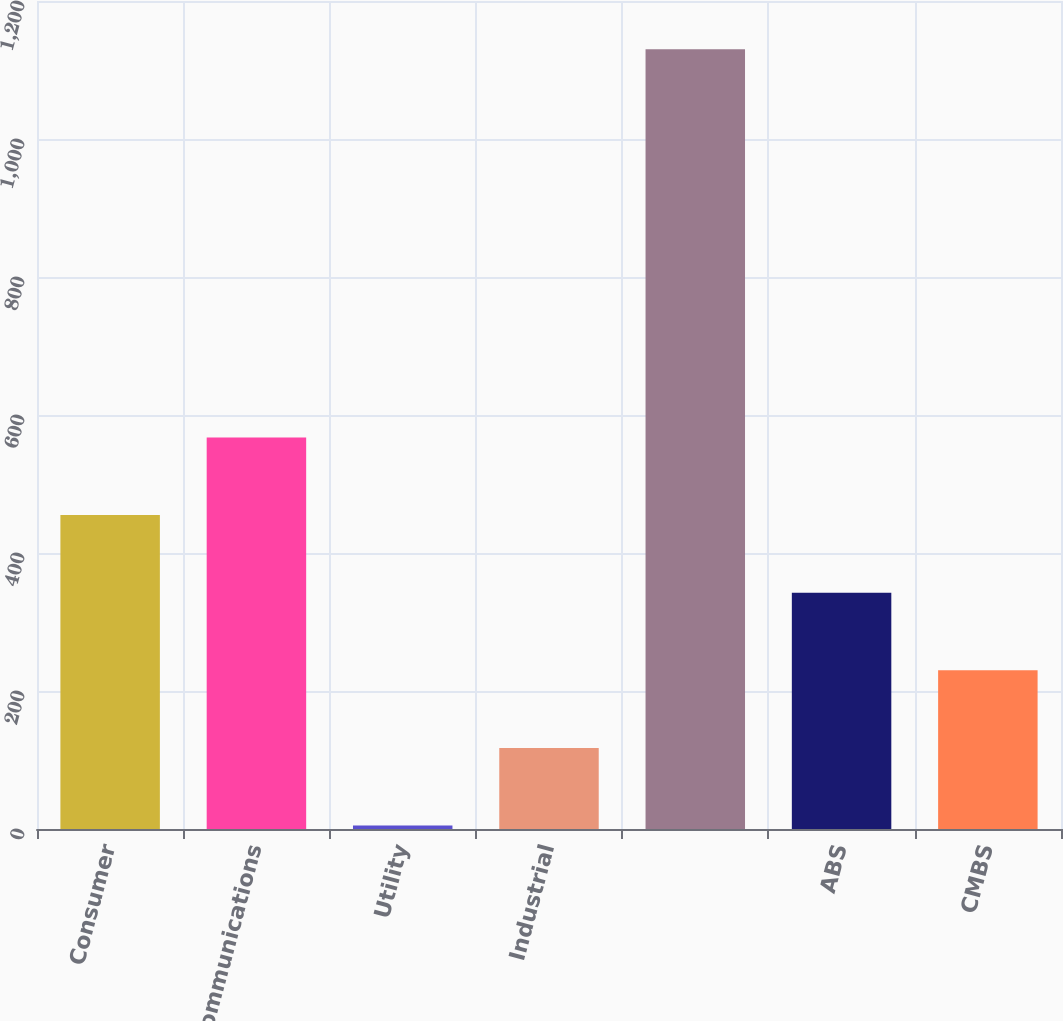<chart> <loc_0><loc_0><loc_500><loc_500><bar_chart><fcel>Consumer<fcel>Communications<fcel>Utility<fcel>Industrial<fcel>Unnamed: 4<fcel>ABS<fcel>CMBS<nl><fcel>455<fcel>567.5<fcel>5<fcel>117.5<fcel>1130<fcel>342.5<fcel>230<nl></chart> 